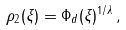Convert formula to latex. <formula><loc_0><loc_0><loc_500><loc_500>\rho _ { 2 } ( \xi ) = \Phi _ { d } ( \xi ) ^ { 1 / \lambda } \, ,</formula> 